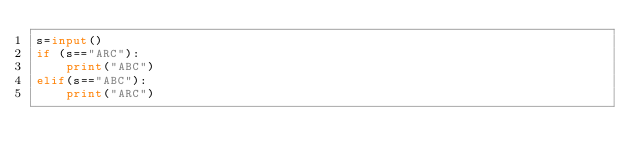<code> <loc_0><loc_0><loc_500><loc_500><_Python_>s=input()
if (s=="ARC"):
    print("ABC")
elif(s=="ABC"):
    print("ARC")</code> 